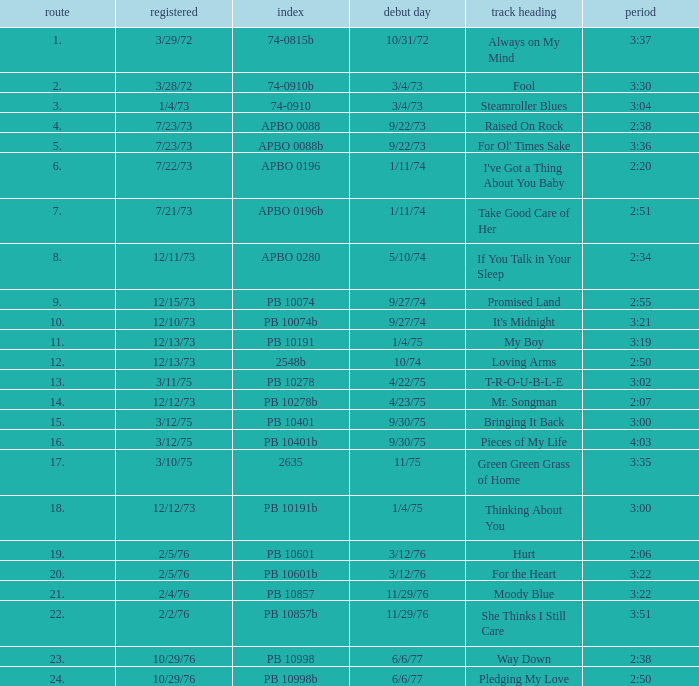Name the catalogue that has tracks less than 13 and the release date of 10/31/72 74-0815b. 